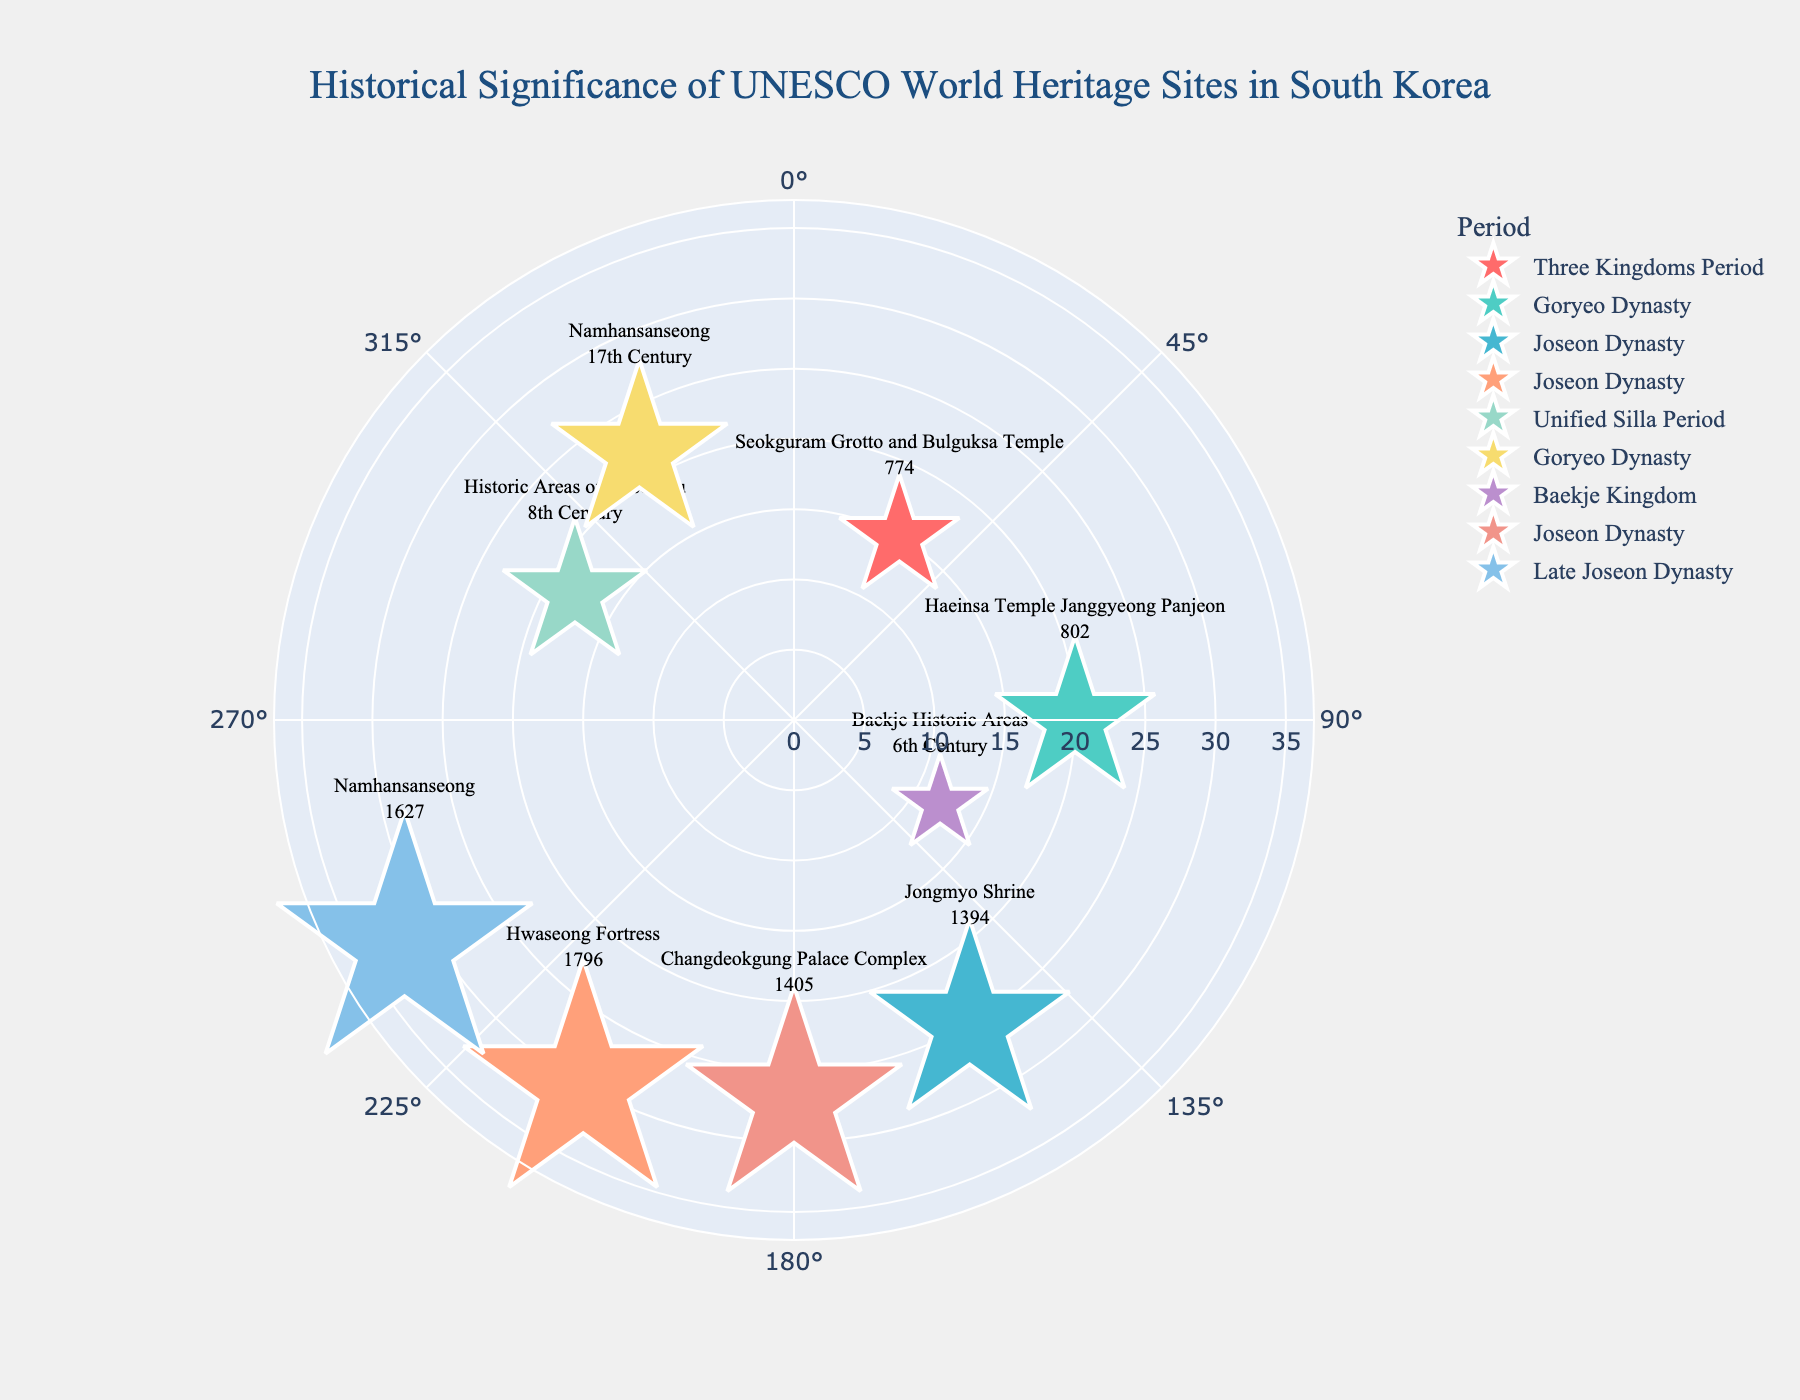What is the title of the figure? The title is prominently displayed at the top center of the figure, giving a clear indication of the content and purpose of the plot.
Answer: Historical Significance of UNESCO World Heritage Sites in South Korea How many UNESCO World Heritage Sites are represented in the figure? Each site is indicated by a marker with associated text, making it straightforward to count their total number.
Answer: 8 Which site has the largest radius and what is its establishment year? The size of the markers is proportional to the radius value, with the largest marker corresponding to the largest radius. The text associated with this marker provides the establishment year.
Answer: Namhansanseong, 1627 Which period has the most associated heritage sites listed? By observing the legend or categorization of markers by period, one can count the number of sites linked to each period.
Answer: Joseon Dynasty What is the average radius value for sites established during the Joseon Dynasty? Identify the radius values for sites labeled under the Joseon Dynasty, sum these values, and divide by the number of these sites to find the average.
Answer: (25 + 30 + 27)/3 = 27.33 Which site is the earliest established according to the figure? The text associated with each data point includes the establishment year, and the earliest can be identified by comparing these years.
Answer: Seokguram Grotto and Bulguksa Temple, 774 Compare the angle values of Hwaseong Fortress and Changdeokgung Palace Complex. Which has a greater angle? Examine the angle values given next to the respective sites and compare the two.
Answer: Hwaseong Fortress, 210; Changdeokgung Palace Complex, 180; Hwaseong Fortress has a greater angle What is the angular position of the Baekje Historic Areas on the plot? The angular position is given next to the data point representing the Baekje Historic Areas.
Answer: 120 Which site from the Goryeo Dynasty is established later, Haeinsa Temple or Namhansanseong? Comparing the establishment years or reference notes such as '17th Century' for the sites in the Goryeo Dynasty cluster will provide the answer.
Answer: Namhansanseong, 17th Century 